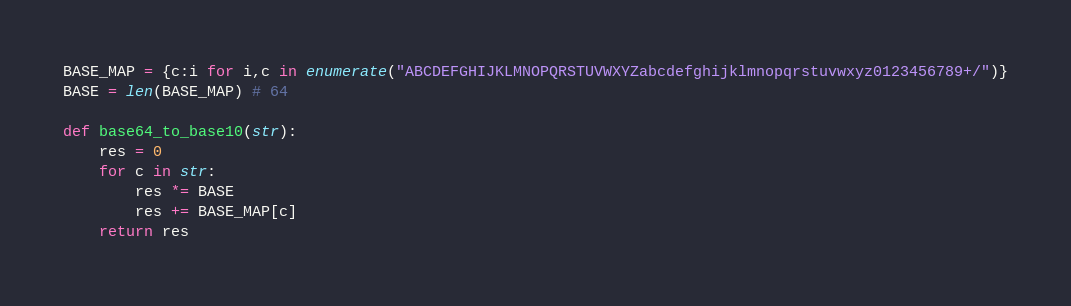<code> <loc_0><loc_0><loc_500><loc_500><_Python_>BASE_MAP = {c:i for i,c in enumerate("ABCDEFGHIJKLMNOPQRSTUVWXYZabcdefghijklmnopqrstuvwxyz0123456789+/")}
BASE = len(BASE_MAP) # 64

def base64_to_base10(str):
    res = 0
    for c in str:
        res *= BASE
        res += BASE_MAP[c]
    return res
</code> 